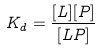Convert formula to latex. <formula><loc_0><loc_0><loc_500><loc_500>K _ { d } = \frac { [ L ] [ P ] } { [ L P ] }</formula> 